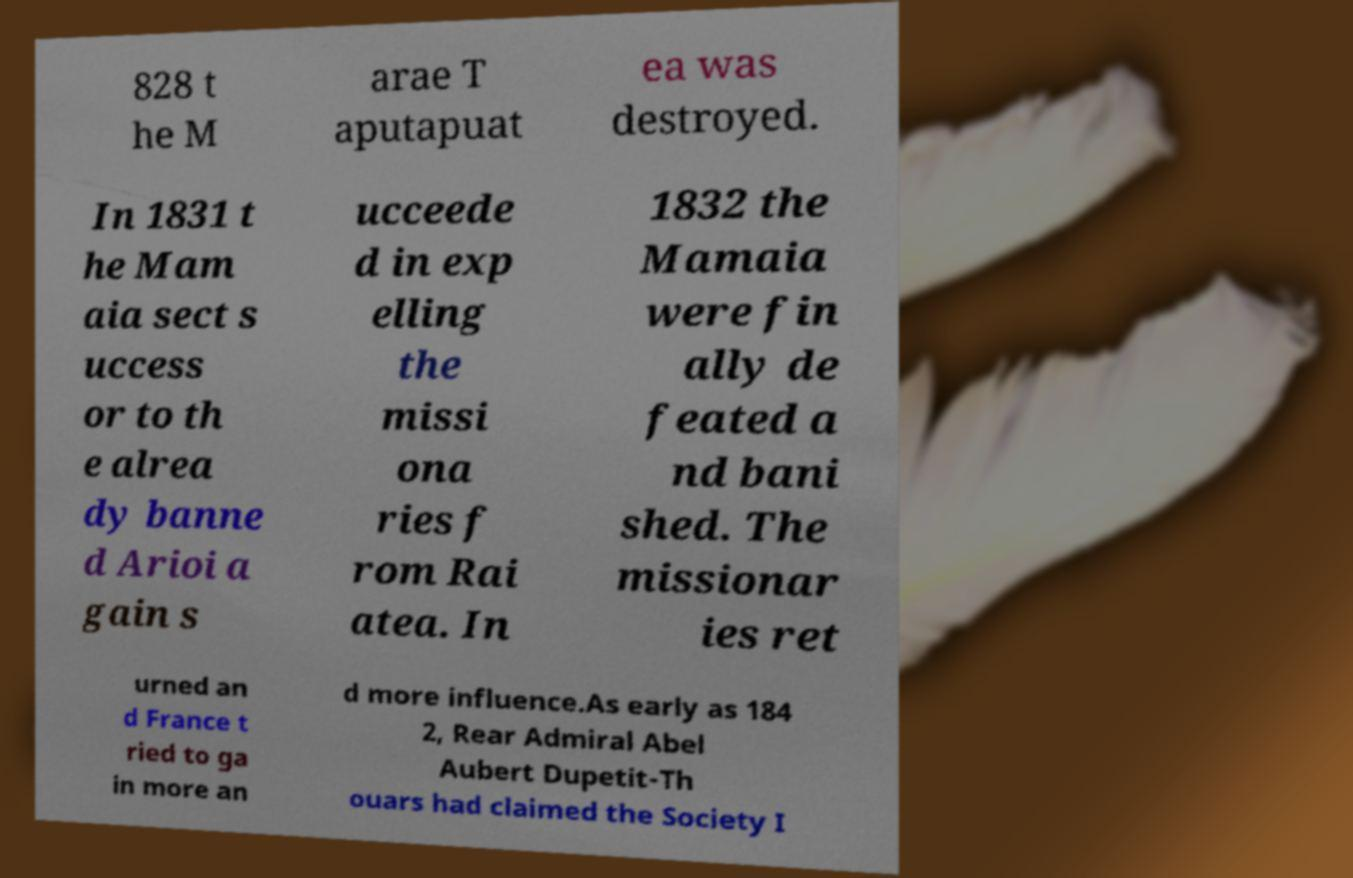Can you accurately transcribe the text from the provided image for me? 828 t he M arae T aputapuat ea was destroyed. In 1831 t he Mam aia sect s uccess or to th e alrea dy banne d Arioi a gain s ucceede d in exp elling the missi ona ries f rom Rai atea. In 1832 the Mamaia were fin ally de feated a nd bani shed. The missionar ies ret urned an d France t ried to ga in more an d more influence.As early as 184 2, Rear Admiral Abel Aubert Dupetit-Th ouars had claimed the Society I 